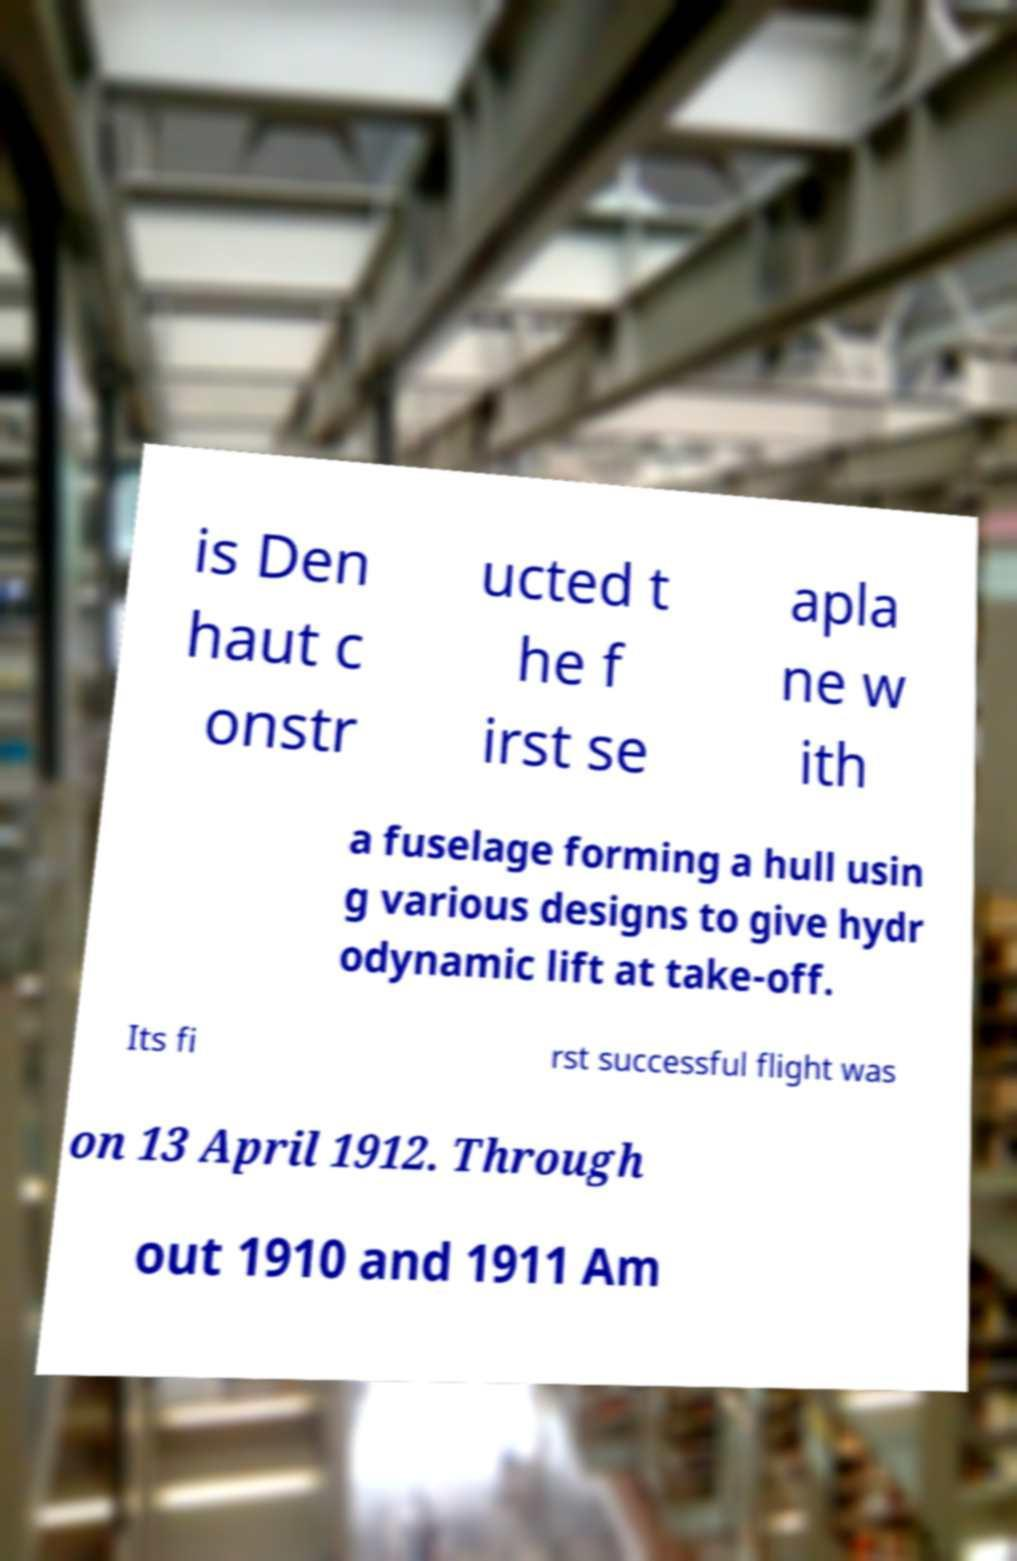What messages or text are displayed in this image? I need them in a readable, typed format. is Den haut c onstr ucted t he f irst se apla ne w ith a fuselage forming a hull usin g various designs to give hydr odynamic lift at take-off. Its fi rst successful flight was on 13 April 1912. Through out 1910 and 1911 Am 